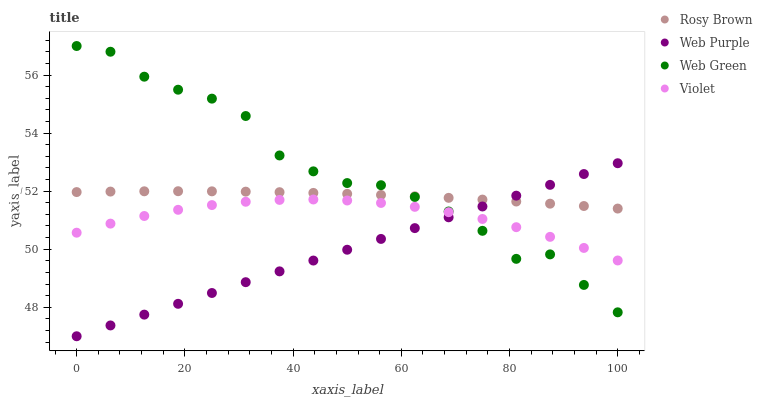Does Web Purple have the minimum area under the curve?
Answer yes or no. Yes. Does Web Green have the maximum area under the curve?
Answer yes or no. Yes. Does Rosy Brown have the minimum area under the curve?
Answer yes or no. No. Does Rosy Brown have the maximum area under the curve?
Answer yes or no. No. Is Web Purple the smoothest?
Answer yes or no. Yes. Is Web Green the roughest?
Answer yes or no. Yes. Is Rosy Brown the smoothest?
Answer yes or no. No. Is Rosy Brown the roughest?
Answer yes or no. No. Does Web Purple have the lowest value?
Answer yes or no. Yes. Does Web Green have the lowest value?
Answer yes or no. No. Does Web Green have the highest value?
Answer yes or no. Yes. Does Rosy Brown have the highest value?
Answer yes or no. No. Is Violet less than Rosy Brown?
Answer yes or no. Yes. Is Rosy Brown greater than Violet?
Answer yes or no. Yes. Does Rosy Brown intersect Web Green?
Answer yes or no. Yes. Is Rosy Brown less than Web Green?
Answer yes or no. No. Is Rosy Brown greater than Web Green?
Answer yes or no. No. Does Violet intersect Rosy Brown?
Answer yes or no. No. 